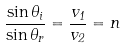Convert formula to latex. <formula><loc_0><loc_0><loc_500><loc_500>\frac { \sin \theta _ { i } } { \sin \theta _ { r } } = \frac { v _ { 1 } } { v _ { 2 } } = n</formula> 